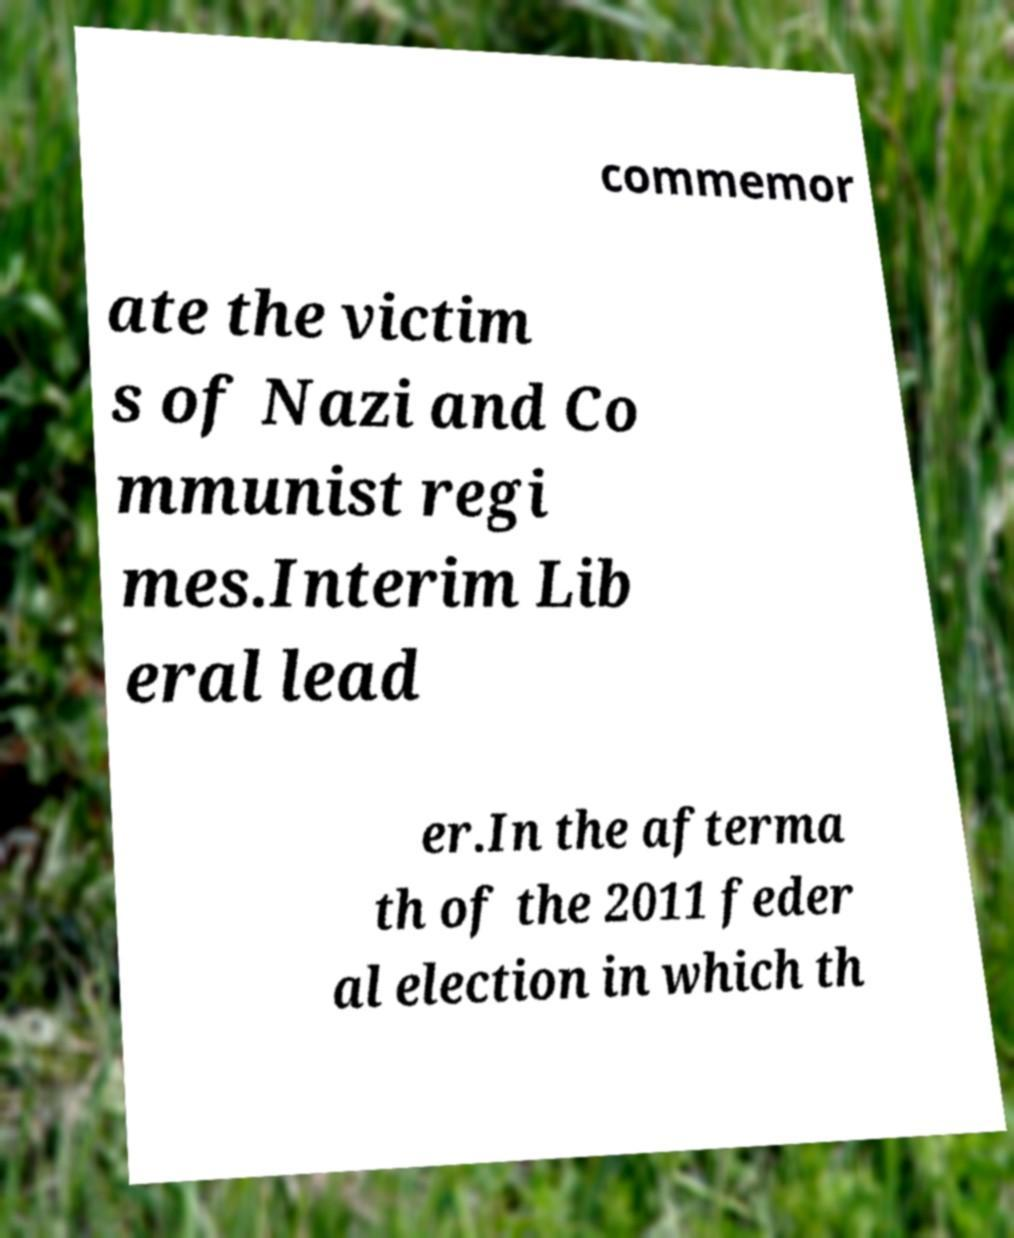Could you assist in decoding the text presented in this image and type it out clearly? commemor ate the victim s of Nazi and Co mmunist regi mes.Interim Lib eral lead er.In the afterma th of the 2011 feder al election in which th 